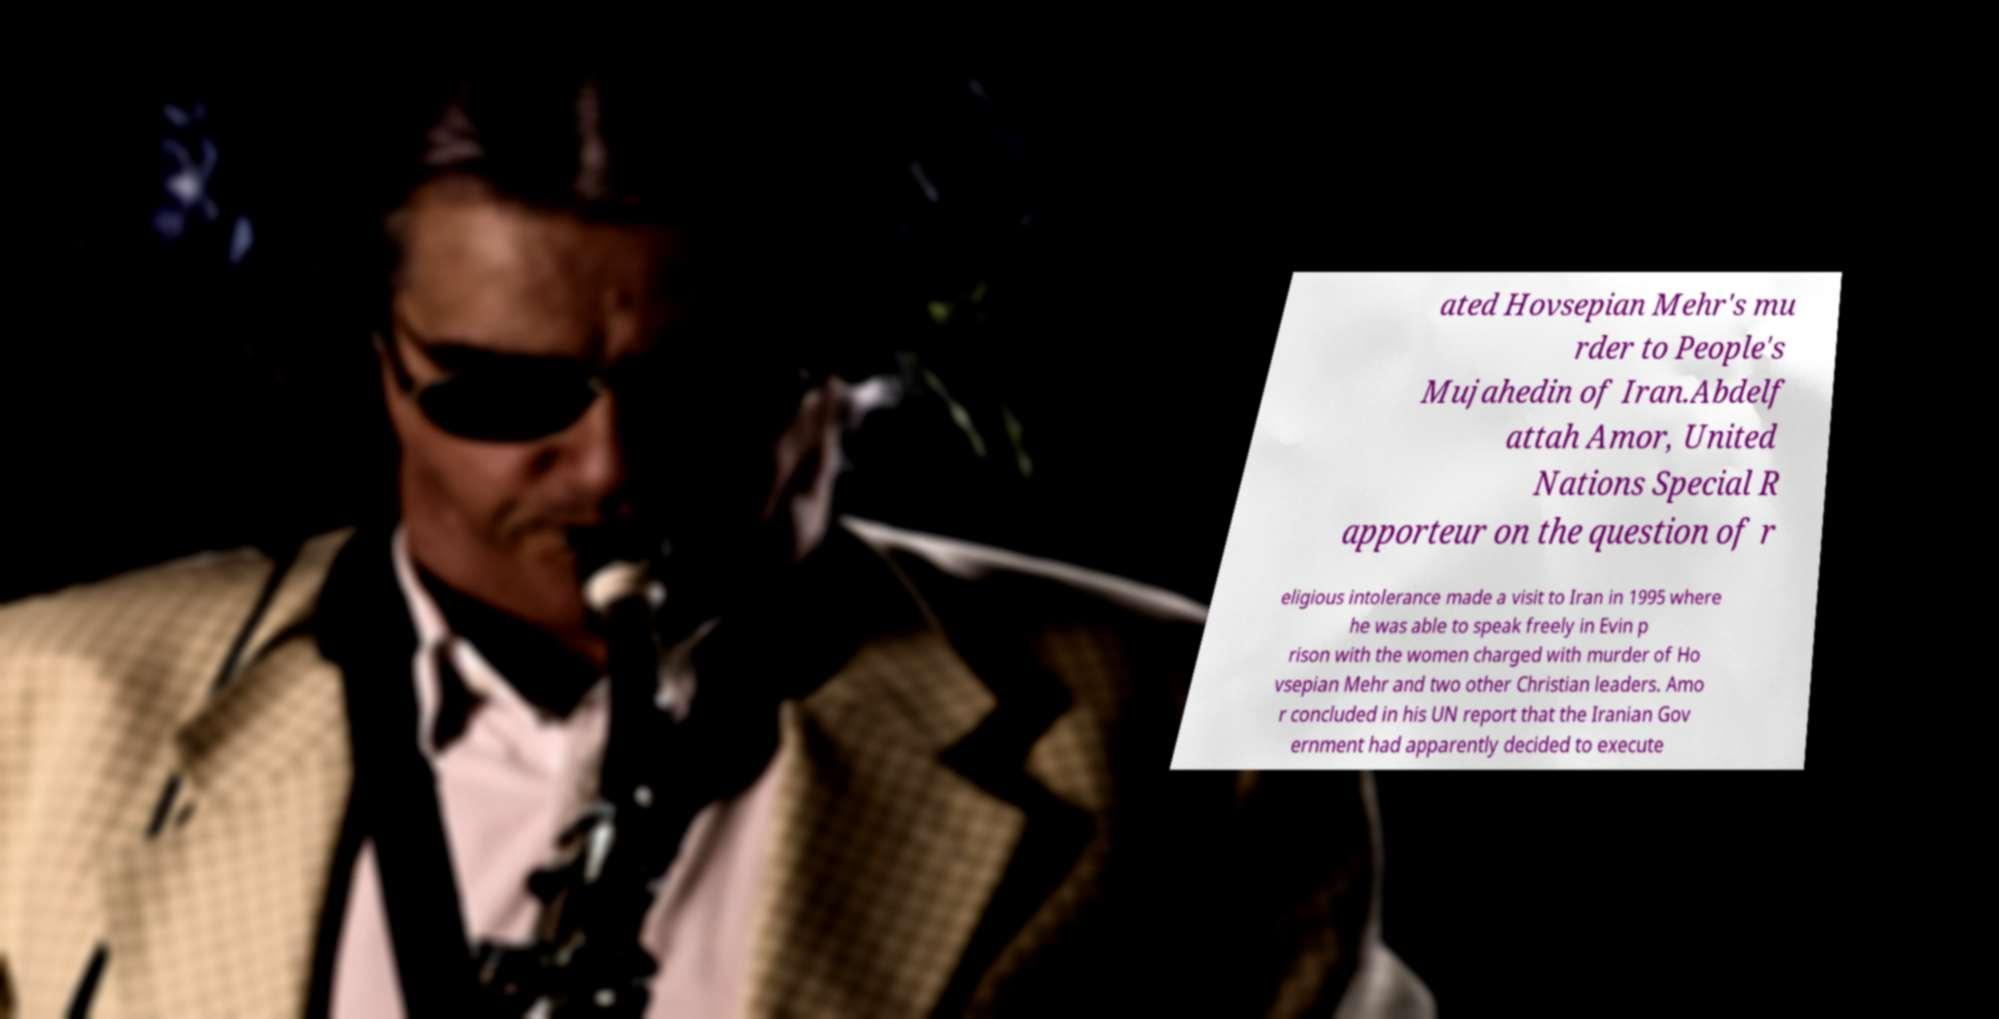For documentation purposes, I need the text within this image transcribed. Could you provide that? ated Hovsepian Mehr's mu rder to People's Mujahedin of Iran.Abdelf attah Amor, United Nations Special R apporteur on the question of r eligious intolerance made a visit to Iran in 1995 where he was able to speak freely in Evin p rison with the women charged with murder of Ho vsepian Mehr and two other Christian leaders. Amo r concluded in his UN report that the Iranian Gov ernment had apparently decided to execute 